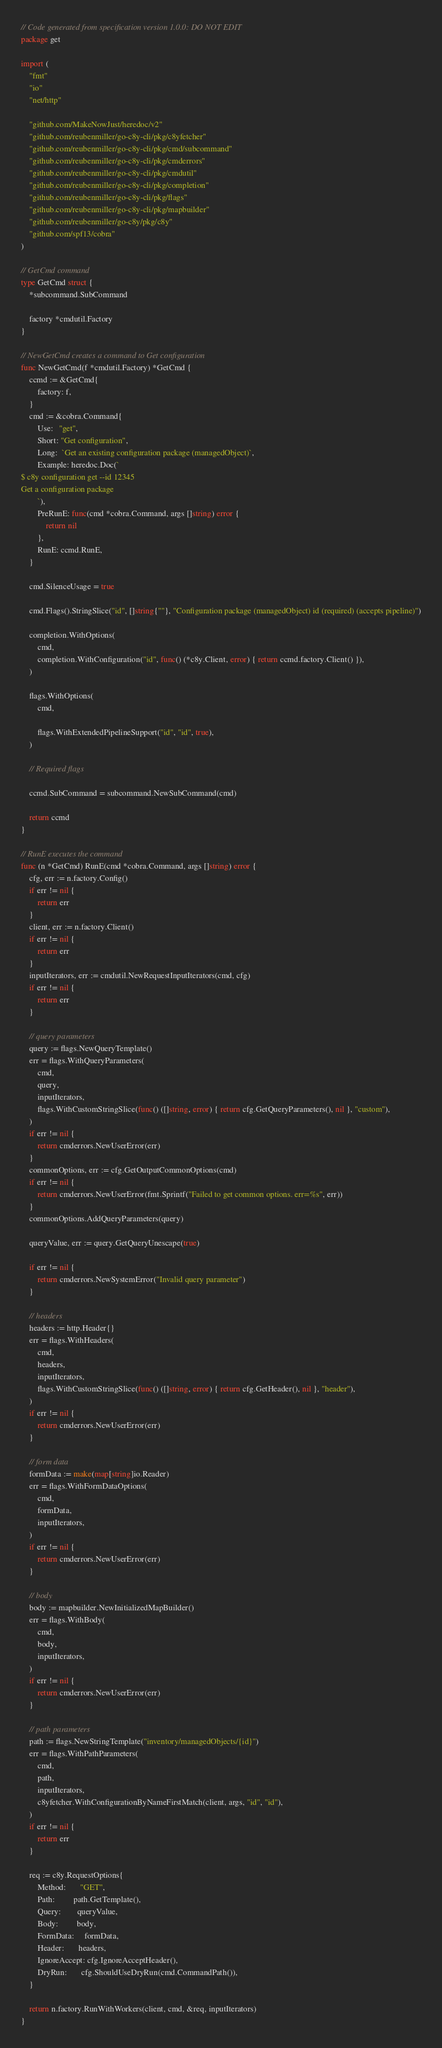Convert code to text. <code><loc_0><loc_0><loc_500><loc_500><_Go_>// Code generated from specification version 1.0.0: DO NOT EDIT
package get

import (
	"fmt"
	"io"
	"net/http"

	"github.com/MakeNowJust/heredoc/v2"
	"github.com/reubenmiller/go-c8y-cli/pkg/c8yfetcher"
	"github.com/reubenmiller/go-c8y-cli/pkg/cmd/subcommand"
	"github.com/reubenmiller/go-c8y-cli/pkg/cmderrors"
	"github.com/reubenmiller/go-c8y-cli/pkg/cmdutil"
	"github.com/reubenmiller/go-c8y-cli/pkg/completion"
	"github.com/reubenmiller/go-c8y-cli/pkg/flags"
	"github.com/reubenmiller/go-c8y-cli/pkg/mapbuilder"
	"github.com/reubenmiller/go-c8y/pkg/c8y"
	"github.com/spf13/cobra"
)

// GetCmd command
type GetCmd struct {
	*subcommand.SubCommand

	factory *cmdutil.Factory
}

// NewGetCmd creates a command to Get configuration
func NewGetCmd(f *cmdutil.Factory) *GetCmd {
	ccmd := &GetCmd{
		factory: f,
	}
	cmd := &cobra.Command{
		Use:   "get",
		Short: "Get configuration",
		Long:  `Get an existing configuration package (managedObject)`,
		Example: heredoc.Doc(`
$ c8y configuration get --id 12345
Get a configuration package
        `),
		PreRunE: func(cmd *cobra.Command, args []string) error {
			return nil
		},
		RunE: ccmd.RunE,
	}

	cmd.SilenceUsage = true

	cmd.Flags().StringSlice("id", []string{""}, "Configuration package (managedObject) id (required) (accepts pipeline)")

	completion.WithOptions(
		cmd,
		completion.WithConfiguration("id", func() (*c8y.Client, error) { return ccmd.factory.Client() }),
	)

	flags.WithOptions(
		cmd,

		flags.WithExtendedPipelineSupport("id", "id", true),
	)

	// Required flags

	ccmd.SubCommand = subcommand.NewSubCommand(cmd)

	return ccmd
}

// RunE executes the command
func (n *GetCmd) RunE(cmd *cobra.Command, args []string) error {
	cfg, err := n.factory.Config()
	if err != nil {
		return err
	}
	client, err := n.factory.Client()
	if err != nil {
		return err
	}
	inputIterators, err := cmdutil.NewRequestInputIterators(cmd, cfg)
	if err != nil {
		return err
	}

	// query parameters
	query := flags.NewQueryTemplate()
	err = flags.WithQueryParameters(
		cmd,
		query,
		inputIterators,
		flags.WithCustomStringSlice(func() ([]string, error) { return cfg.GetQueryParameters(), nil }, "custom"),
	)
	if err != nil {
		return cmderrors.NewUserError(err)
	}
	commonOptions, err := cfg.GetOutputCommonOptions(cmd)
	if err != nil {
		return cmderrors.NewUserError(fmt.Sprintf("Failed to get common options. err=%s", err))
	}
	commonOptions.AddQueryParameters(query)

	queryValue, err := query.GetQueryUnescape(true)

	if err != nil {
		return cmderrors.NewSystemError("Invalid query parameter")
	}

	// headers
	headers := http.Header{}
	err = flags.WithHeaders(
		cmd,
		headers,
		inputIterators,
		flags.WithCustomStringSlice(func() ([]string, error) { return cfg.GetHeader(), nil }, "header"),
	)
	if err != nil {
		return cmderrors.NewUserError(err)
	}

	// form data
	formData := make(map[string]io.Reader)
	err = flags.WithFormDataOptions(
		cmd,
		formData,
		inputIterators,
	)
	if err != nil {
		return cmderrors.NewUserError(err)
	}

	// body
	body := mapbuilder.NewInitializedMapBuilder()
	err = flags.WithBody(
		cmd,
		body,
		inputIterators,
	)
	if err != nil {
		return cmderrors.NewUserError(err)
	}

	// path parameters
	path := flags.NewStringTemplate("inventory/managedObjects/{id}")
	err = flags.WithPathParameters(
		cmd,
		path,
		inputIterators,
		c8yfetcher.WithConfigurationByNameFirstMatch(client, args, "id", "id"),
	)
	if err != nil {
		return err
	}

	req := c8y.RequestOptions{
		Method:       "GET",
		Path:         path.GetTemplate(),
		Query:        queryValue,
		Body:         body,
		FormData:     formData,
		Header:       headers,
		IgnoreAccept: cfg.IgnoreAcceptHeader(),
		DryRun:       cfg.ShouldUseDryRun(cmd.CommandPath()),
	}

	return n.factory.RunWithWorkers(client, cmd, &req, inputIterators)
}
</code> 